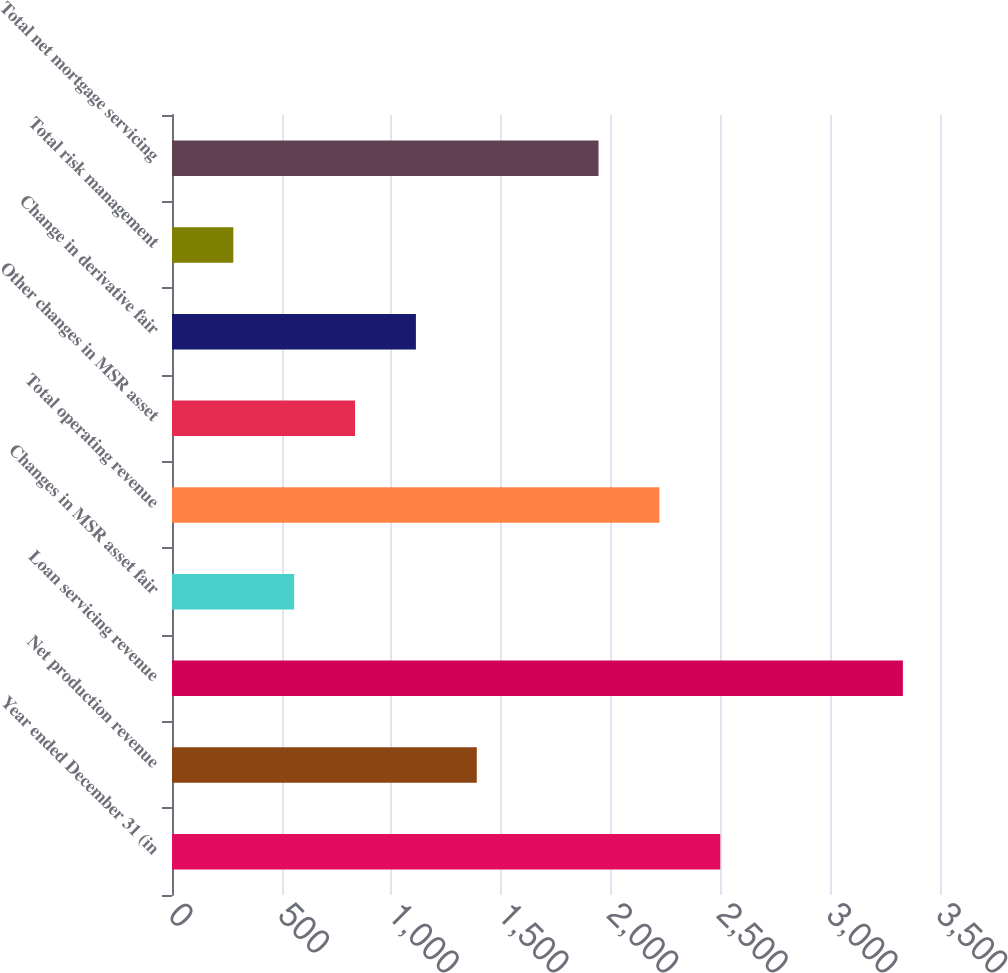Convert chart. <chart><loc_0><loc_0><loc_500><loc_500><bar_chart><fcel>Year ended December 31 (in<fcel>Net production revenue<fcel>Loan servicing revenue<fcel>Changes in MSR asset fair<fcel>Total operating revenue<fcel>Other changes in MSR asset<fcel>Change in derivative fair<fcel>Total risk management<fcel>Total net mortgage servicing<nl><fcel>2498.6<fcel>1389<fcel>3330.8<fcel>556.8<fcel>2221.2<fcel>834.2<fcel>1111.6<fcel>279.4<fcel>1943.8<nl></chart> 